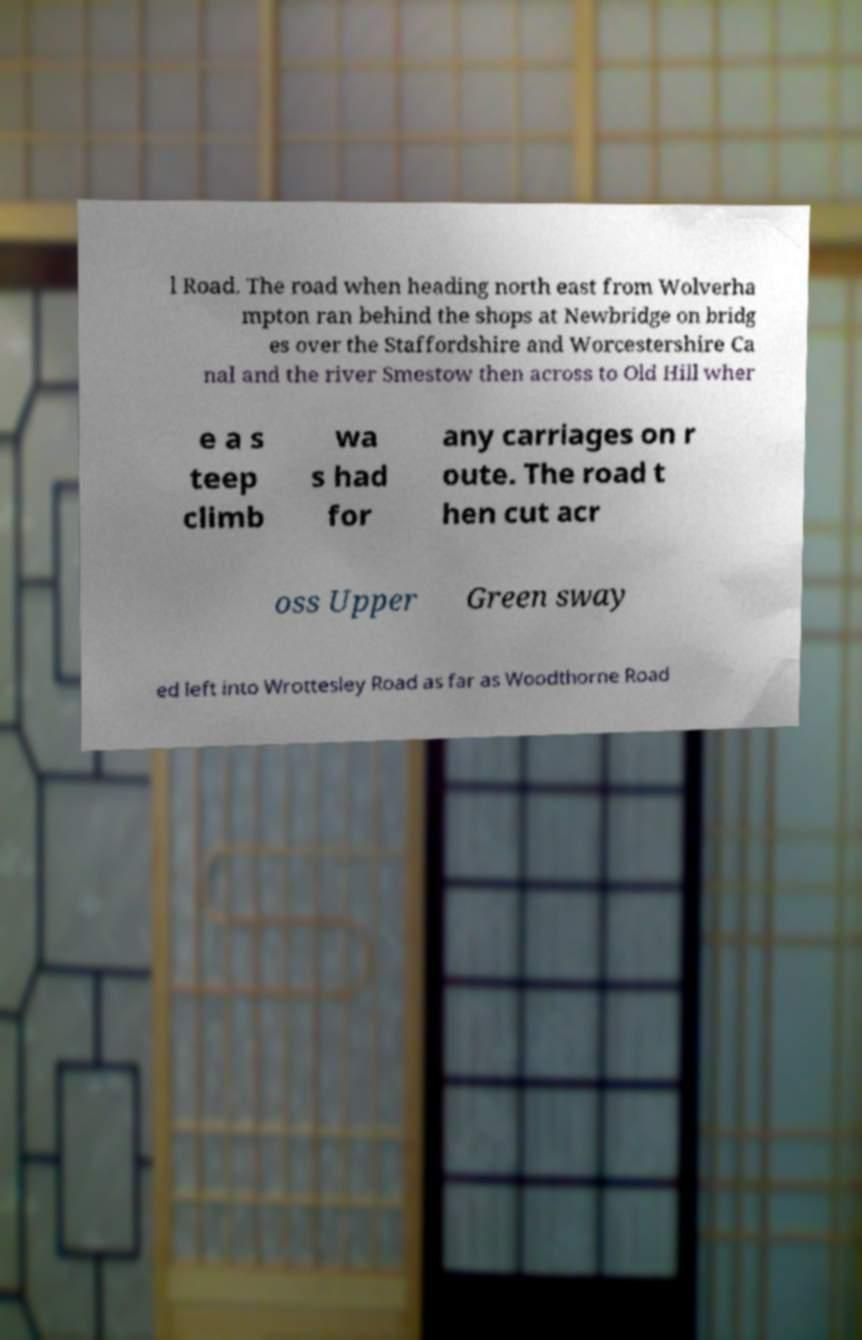There's text embedded in this image that I need extracted. Can you transcribe it verbatim? l Road. The road when heading north east from Wolverha mpton ran behind the shops at Newbridge on bridg es over the Staffordshire and Worcestershire Ca nal and the river Smestow then across to Old Hill wher e a s teep climb wa s had for any carriages on r oute. The road t hen cut acr oss Upper Green sway ed left into Wrottesley Road as far as Woodthorne Road 